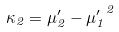<formula> <loc_0><loc_0><loc_500><loc_500>\kappa _ { 2 } = \mu _ { 2 } ^ { \prime } - { \mu _ { 1 } ^ { \prime } } ^ { 2 }</formula> 